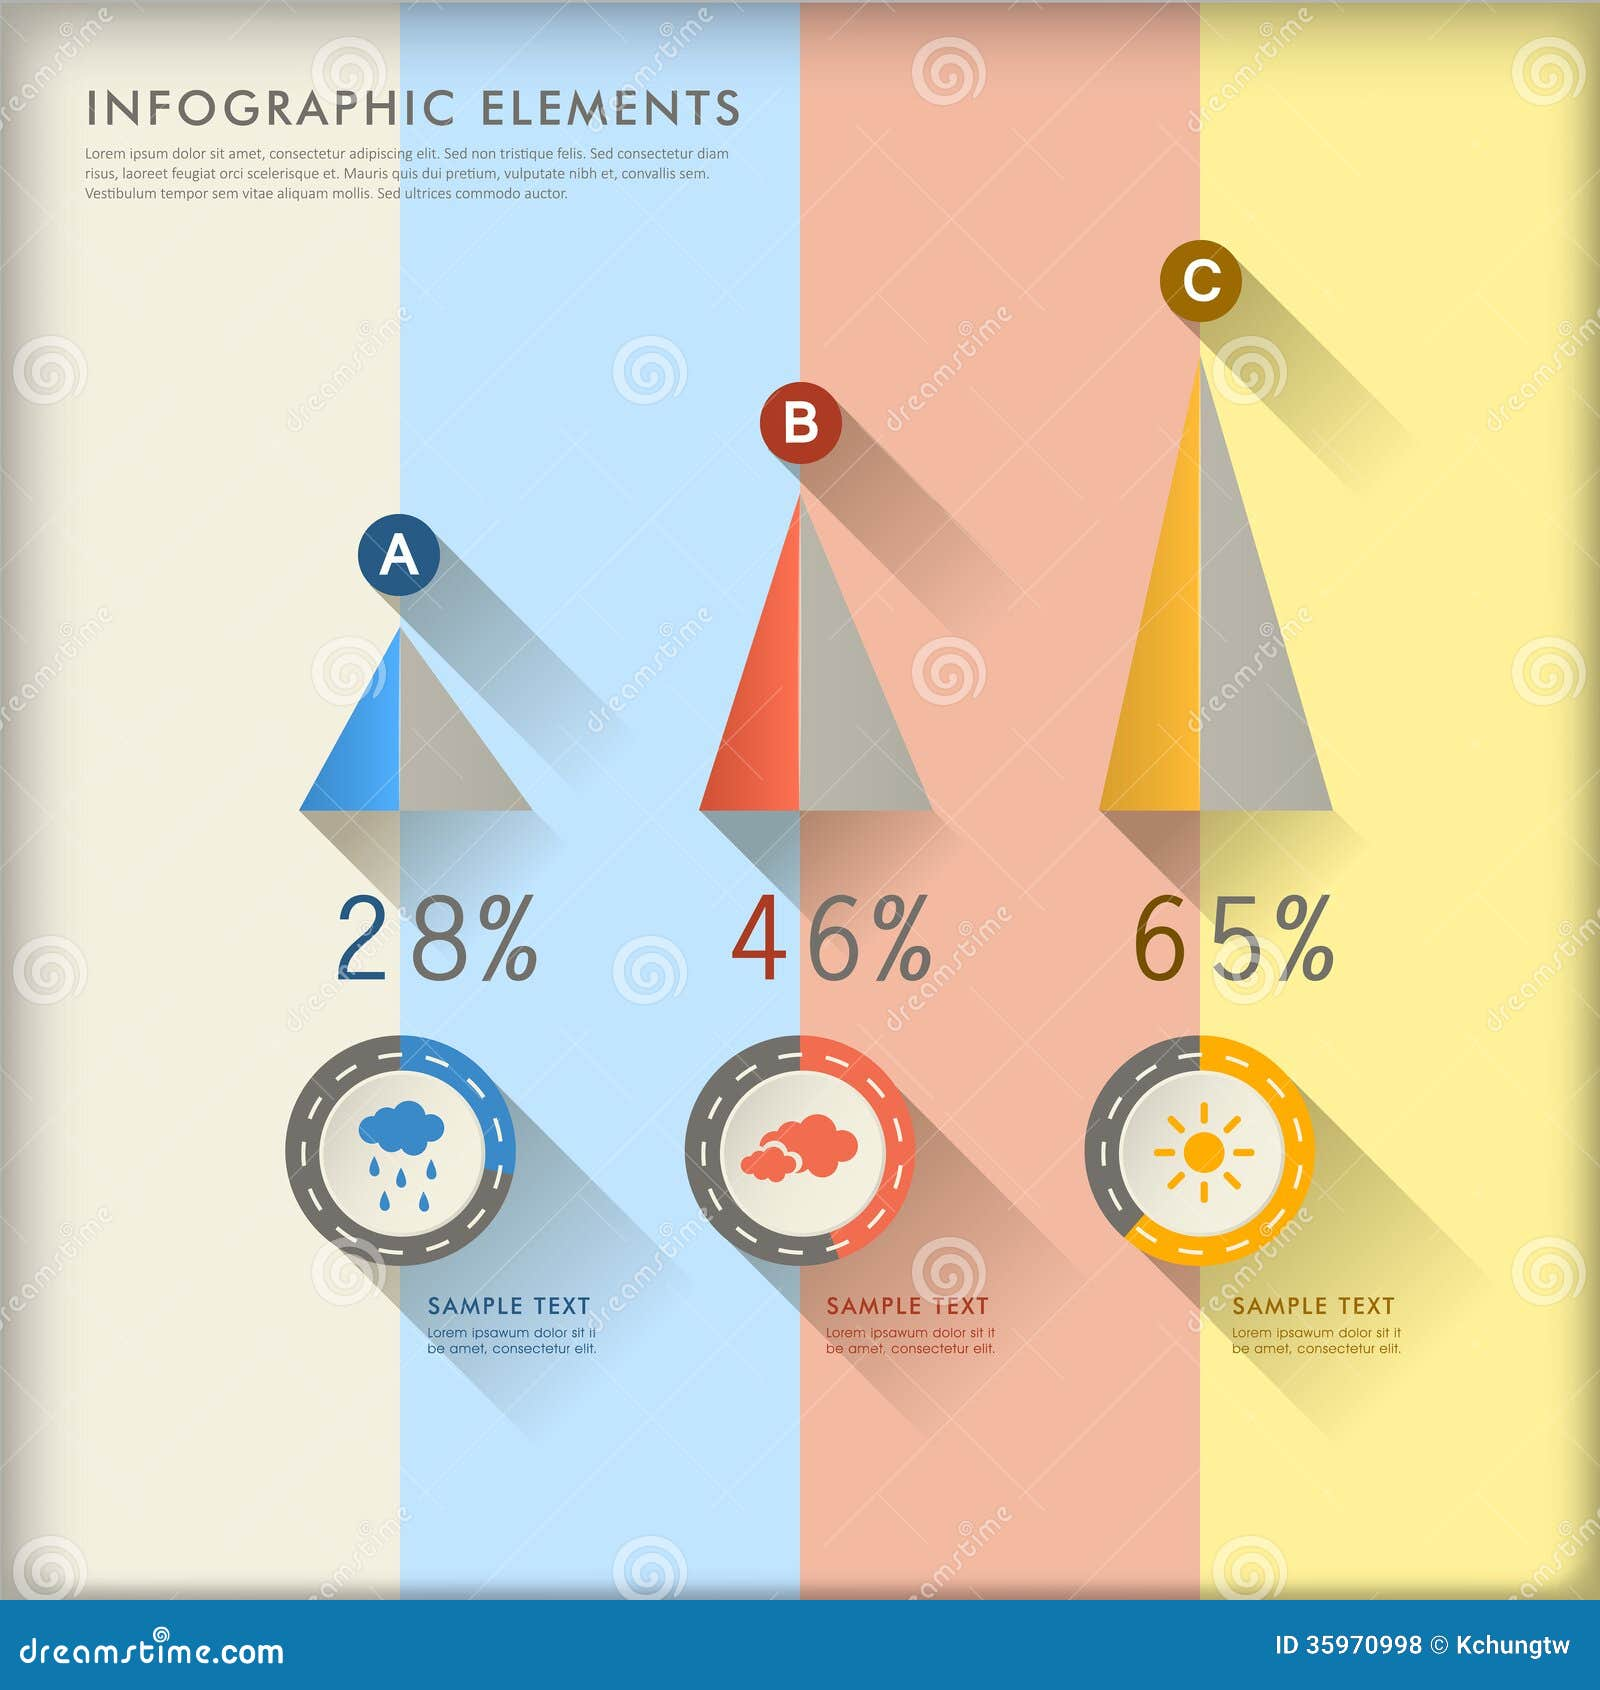Imagine this infographic represents three different types of emotions. How might you interpret these visual elements and percentages in that context? If we interpret this infographic as representing three different types of emotions, the icons and percentages could symbolize the prevalence or intensity of these emotions within a group or over a period of time. For instance, the rain cloud could represent sadness or melancholy, the red cloud might symbolize anger or frustration, and the sun could signify happiness or positivity. The percentages would then indicate how frequently each emotion occurs or is experienced, with 28% denoting sadness, 46% indicating anger, and 65% representing happiness. This interpretation highlights the emotional landscape within the given context, underscoring the dominance of certain feelings over others. 